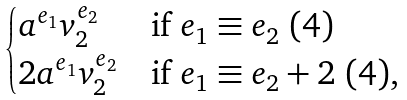Convert formula to latex. <formula><loc_0><loc_0><loc_500><loc_500>\begin{cases} a ^ { e _ { 1 } } v _ { 2 } ^ { e _ { 2 } } & \text {if } e _ { 1 } \equiv e _ { 2 } \ ( 4 ) \\ 2 a ^ { e _ { 1 } } v _ { 2 } ^ { e _ { 2 } } & \text {if } e _ { 1 } \equiv e _ { 2 } + 2 \ ( 4 ) , \end{cases}</formula> 